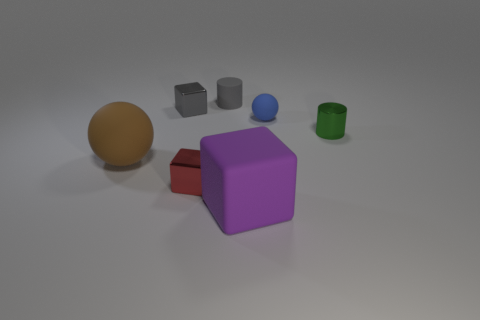Is the number of small gray things that are in front of the rubber cylinder greater than the number of brown spheres on the right side of the brown matte object?
Give a very brief answer. Yes. There is a gray thing behind the small gray block; what is it made of?
Offer a terse response. Rubber. Does the green shiny object have the same shape as the purple rubber object?
Make the answer very short. No. Is there anything else that has the same color as the small metal cylinder?
Your response must be concise. No. What color is the other thing that is the same shape as the blue rubber thing?
Your answer should be compact. Brown. Are there more cylinders that are in front of the tiny gray cube than big gray metallic cubes?
Your answer should be compact. Yes. There is a large thing on the left side of the purple cube; what color is it?
Your answer should be very brief. Brown. Do the blue object and the brown rubber thing have the same size?
Offer a very short reply. No. The gray shiny cube has what size?
Your response must be concise. Small. The tiny metallic thing that is the same color as the matte cylinder is what shape?
Provide a succinct answer. Cube. 